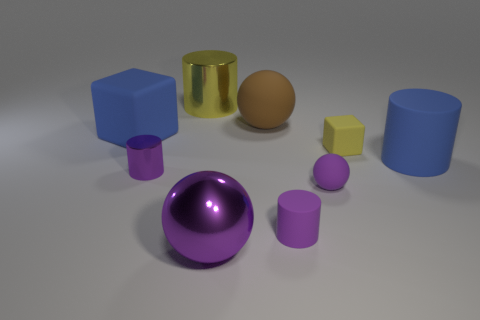Subtract all purple cylinders. How many were subtracted if there are1purple cylinders left? 1 Subtract all blue cylinders. How many cylinders are left? 3 Subtract all blue rubber cylinders. How many cylinders are left? 3 Subtract all blocks. How many objects are left? 7 Subtract 1 blocks. How many blocks are left? 1 Subtract all cyan balls. Subtract all yellow cylinders. How many balls are left? 3 Subtract all green balls. How many gray cubes are left? 0 Subtract all large blue metal cylinders. Subtract all large blue cubes. How many objects are left? 8 Add 2 balls. How many balls are left? 5 Add 8 blue shiny blocks. How many blue shiny blocks exist? 8 